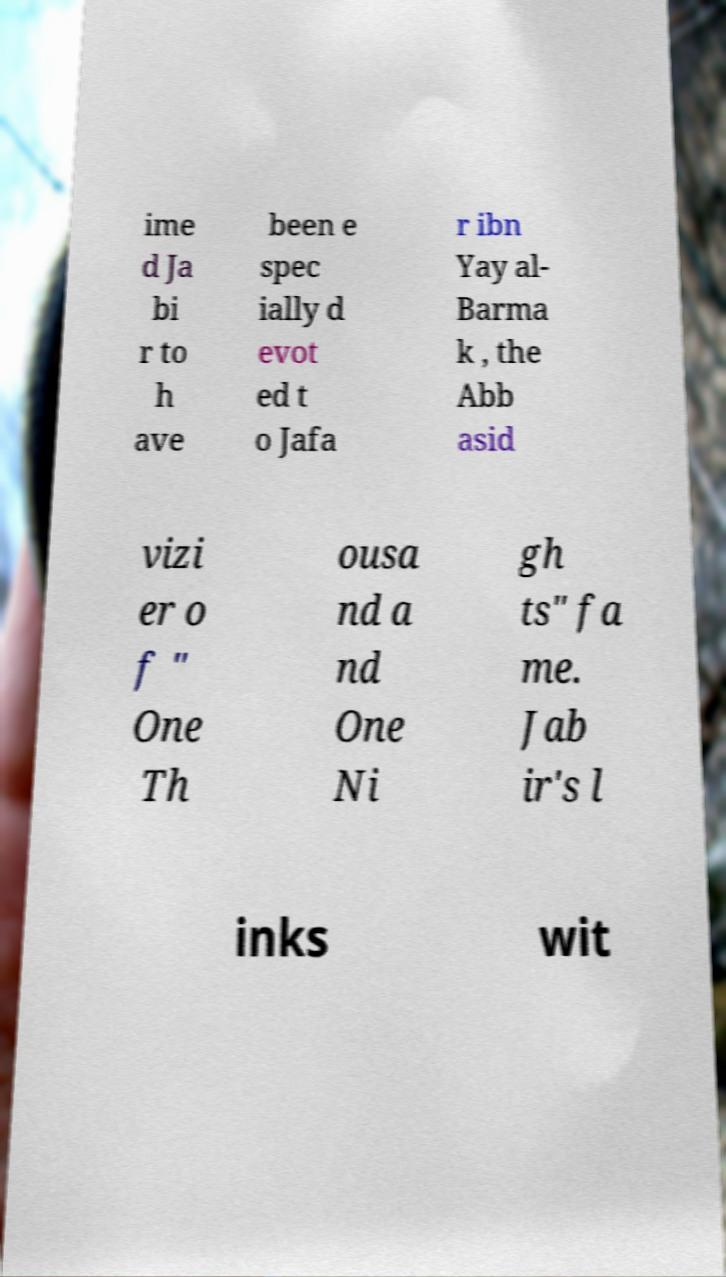For documentation purposes, I need the text within this image transcribed. Could you provide that? ime d Ja bi r to h ave been e spec ially d evot ed t o Jafa r ibn Yay al- Barma k , the Abb asid vizi er o f " One Th ousa nd a nd One Ni gh ts" fa me. Jab ir's l inks wit 